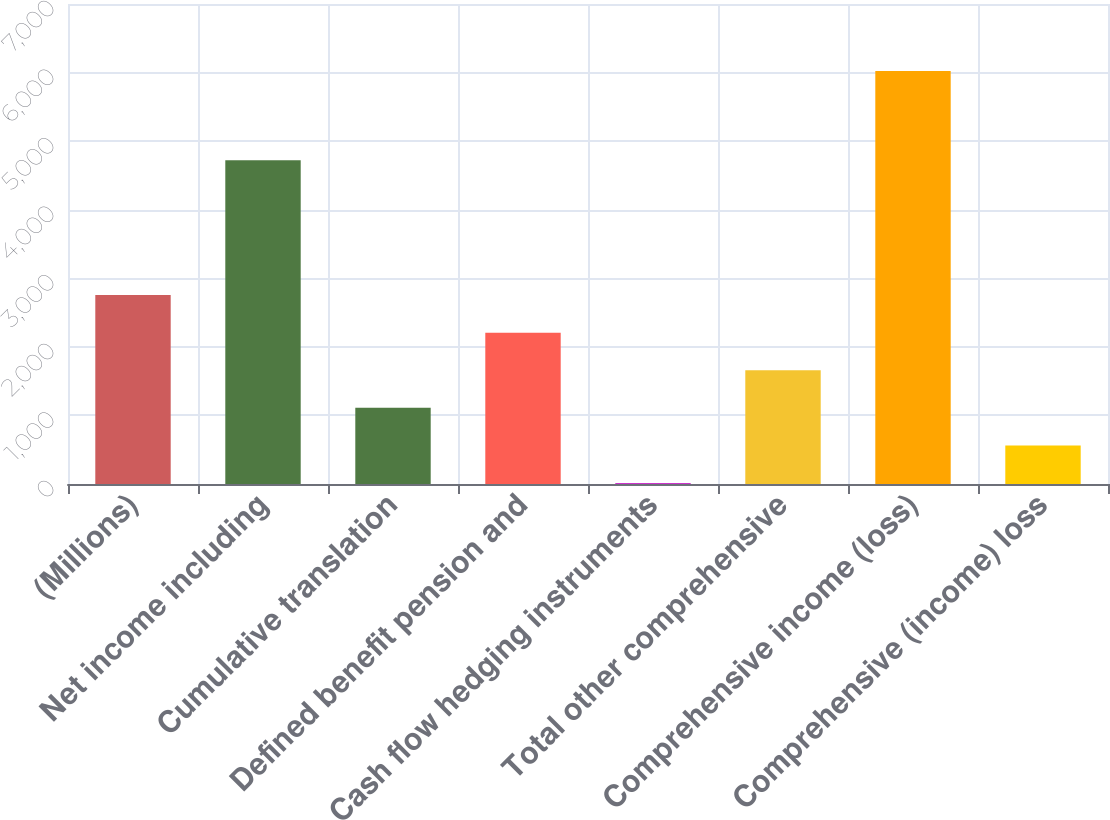Convert chart. <chart><loc_0><loc_0><loc_500><loc_500><bar_chart><fcel>(Millions)<fcel>Net income including<fcel>Cumulative translation<fcel>Defined benefit pension and<fcel>Cash flow hedging instruments<fcel>Total other comprehensive<fcel>Comprehensive income (loss)<fcel>Comprehensive (income) loss<nl><fcel>2755.5<fcel>4721<fcel>1111.2<fcel>2207.4<fcel>15<fcel>1659.3<fcel>6024.1<fcel>563.1<nl></chart> 